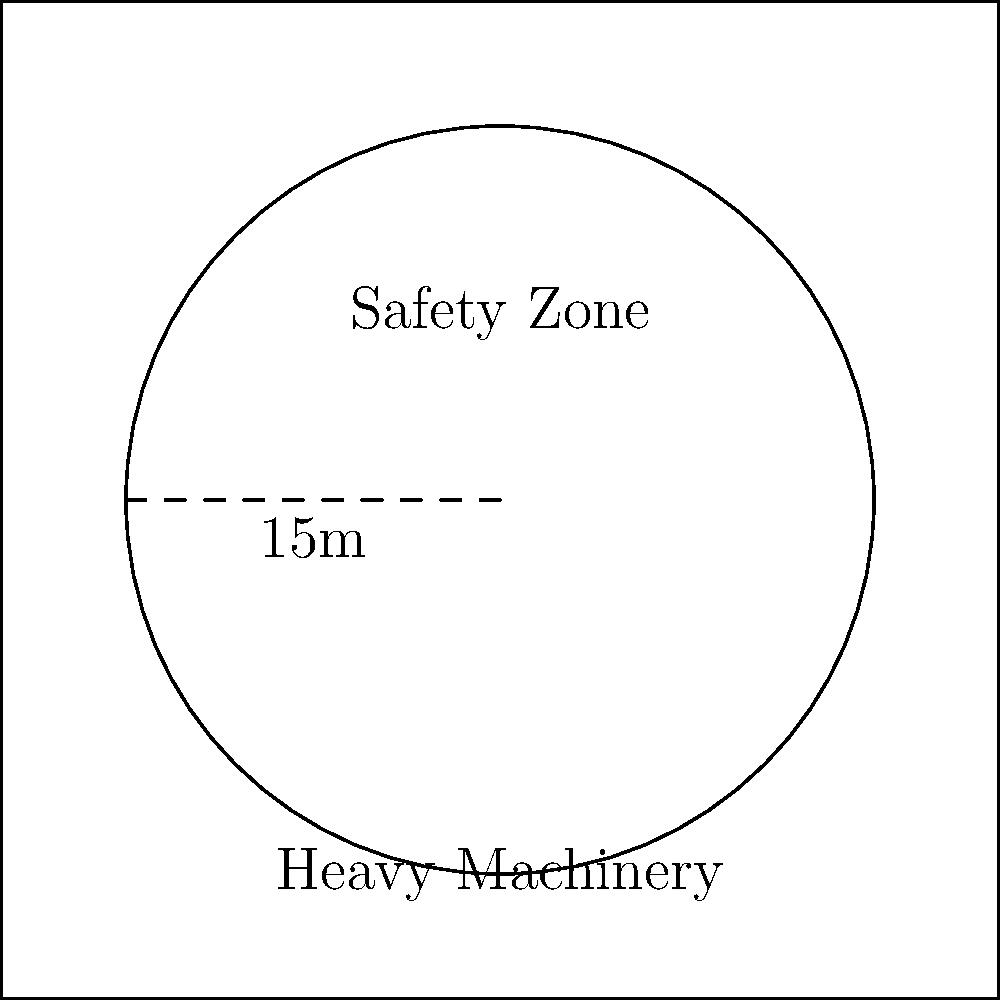A circular safety zone is established around a piece of heavy machinery on a construction site. If the radius of this safety zone is 15 meters, what is the total area that workers must avoid while the machinery is in operation? To solve this problem, we need to calculate the area of a circle given its radius. Let's break it down step-by-step:

1. Recall the formula for the area of a circle:
   $A = \pi r^2$, where $A$ is the area and $r$ is the radius.

2. We are given that the radius is 15 meters.

3. Substitute the radius into the formula:
   $A = \pi (15)^2$

4. Simplify:
   $A = \pi (225)$

5. Calculate:
   $A = 706.86$ (rounded to two decimal places)

Therefore, the area of the safety zone is approximately 706.86 square meters.
Answer: $706.86 \text{ m}^2$ 